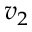<formula> <loc_0><loc_0><loc_500><loc_500>v _ { 2 }</formula> 